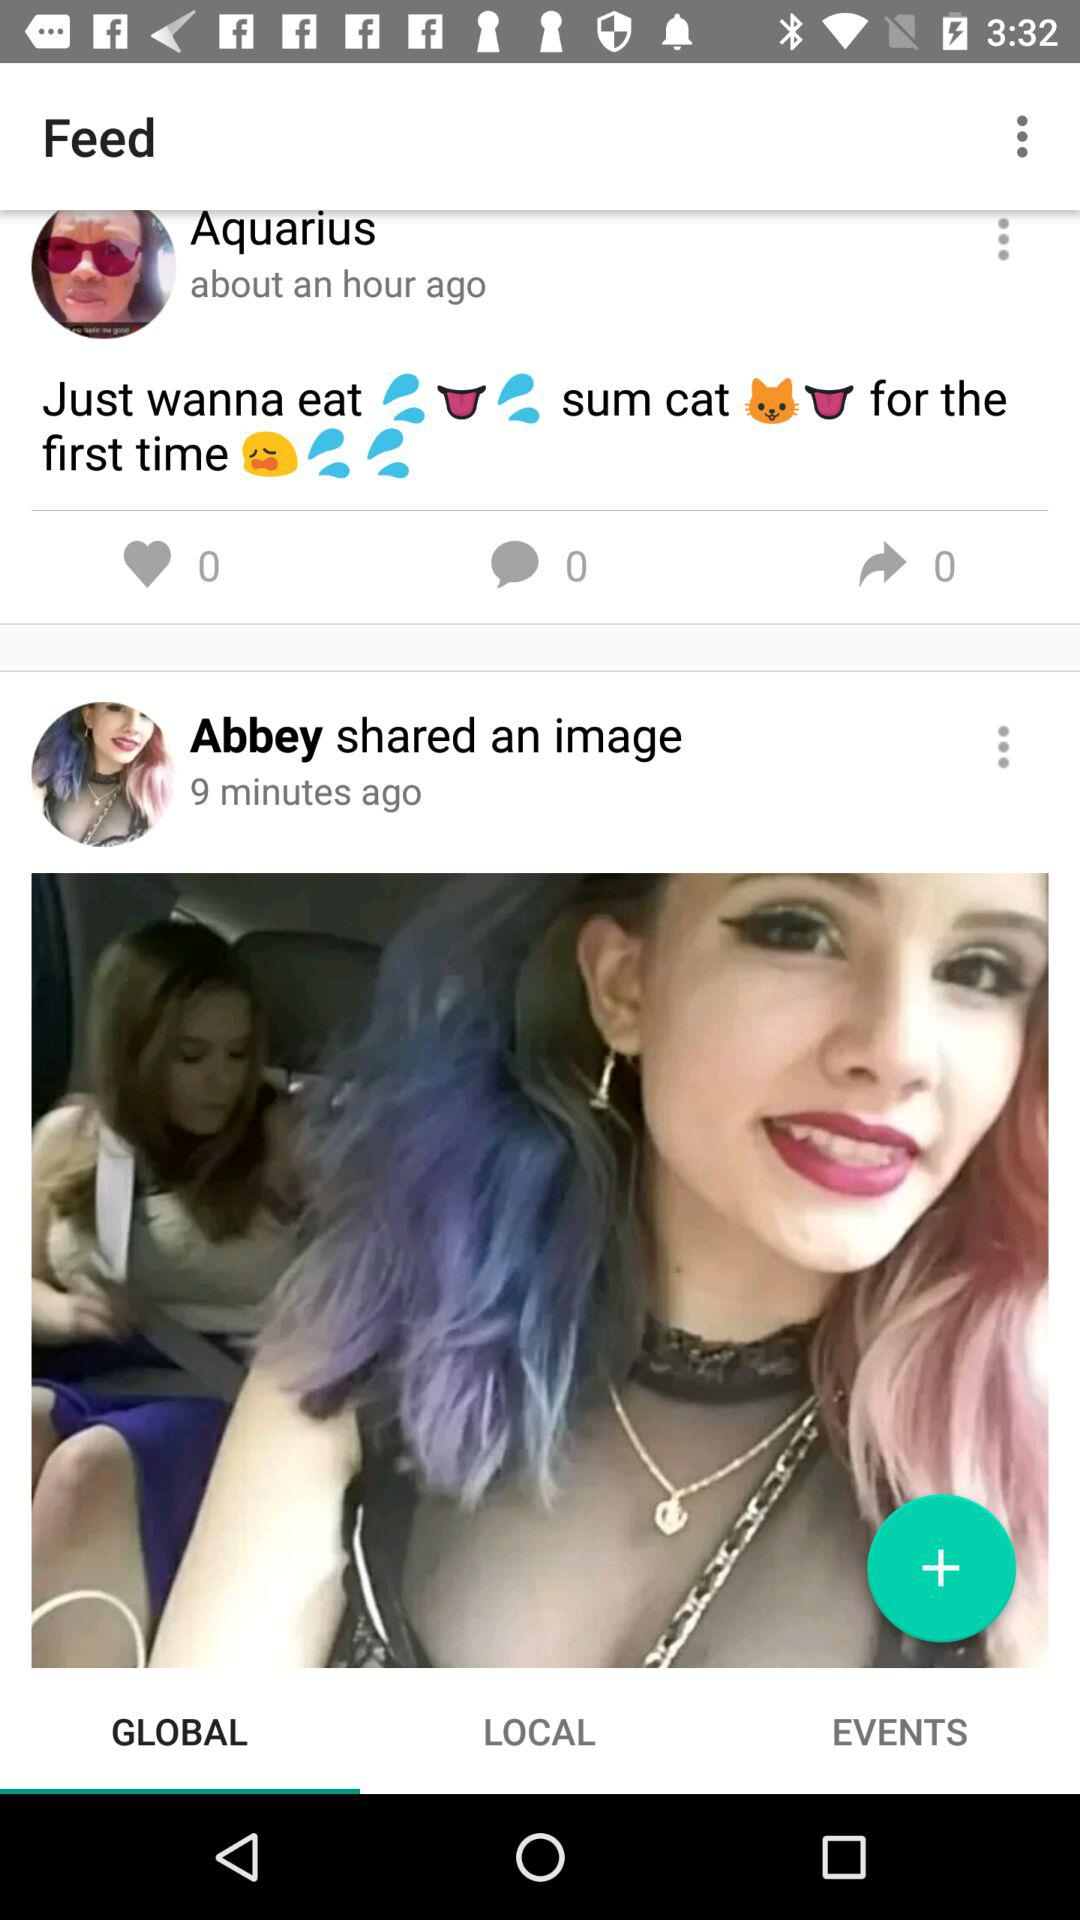How many likes are there on Aquarius's post? There are 0 likes. 